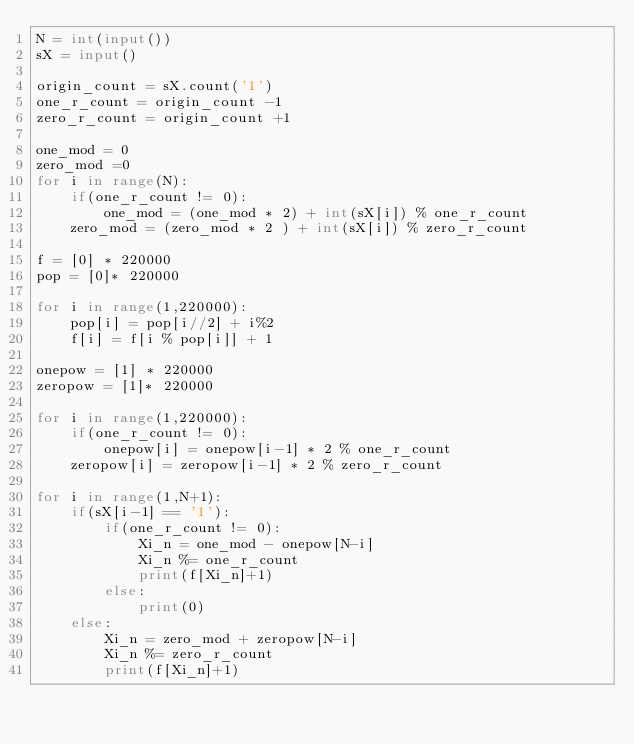<code> <loc_0><loc_0><loc_500><loc_500><_Python_>N = int(input())
sX = input()

origin_count = sX.count('1')
one_r_count = origin_count -1
zero_r_count = origin_count +1

one_mod = 0
zero_mod =0
for i in range(N):
    if(one_r_count != 0):
        one_mod = (one_mod * 2) + int(sX[i]) % one_r_count
    zero_mod = (zero_mod * 2 ) + int(sX[i]) % zero_r_count

f = [0] * 220000
pop = [0]* 220000

for i in range(1,220000):
    pop[i] = pop[i//2] + i%2
    f[i] = f[i % pop[i]] + 1

onepow = [1] * 220000
zeropow = [1]* 220000

for i in range(1,220000):
    if(one_r_count != 0):
        onepow[i] = onepow[i-1] * 2 % one_r_count
    zeropow[i] = zeropow[i-1] * 2 % zero_r_count

for i in range(1,N+1):
    if(sX[i-1] == '1'):
        if(one_r_count != 0):
            Xi_n = one_mod - onepow[N-i]
            Xi_n %= one_r_count
            print(f[Xi_n]+1)
        else:
            print(0)
    else:
        Xi_n = zero_mod + zeropow[N-i]
        Xi_n %= zero_r_count
        print(f[Xi_n]+1)

</code> 